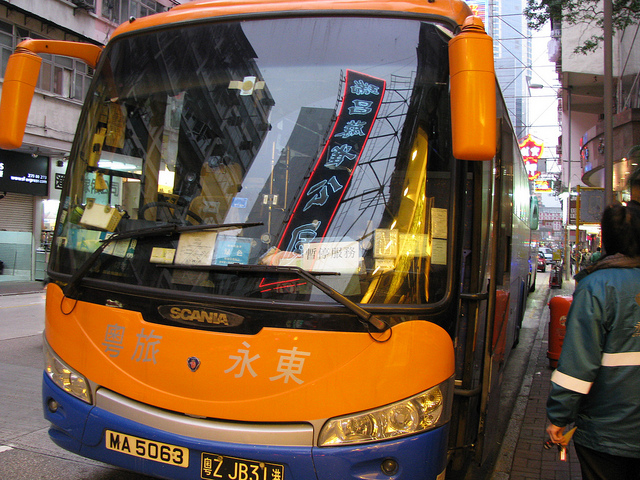Please transcribe the text in this image. SCANIA MA Z JB 3 